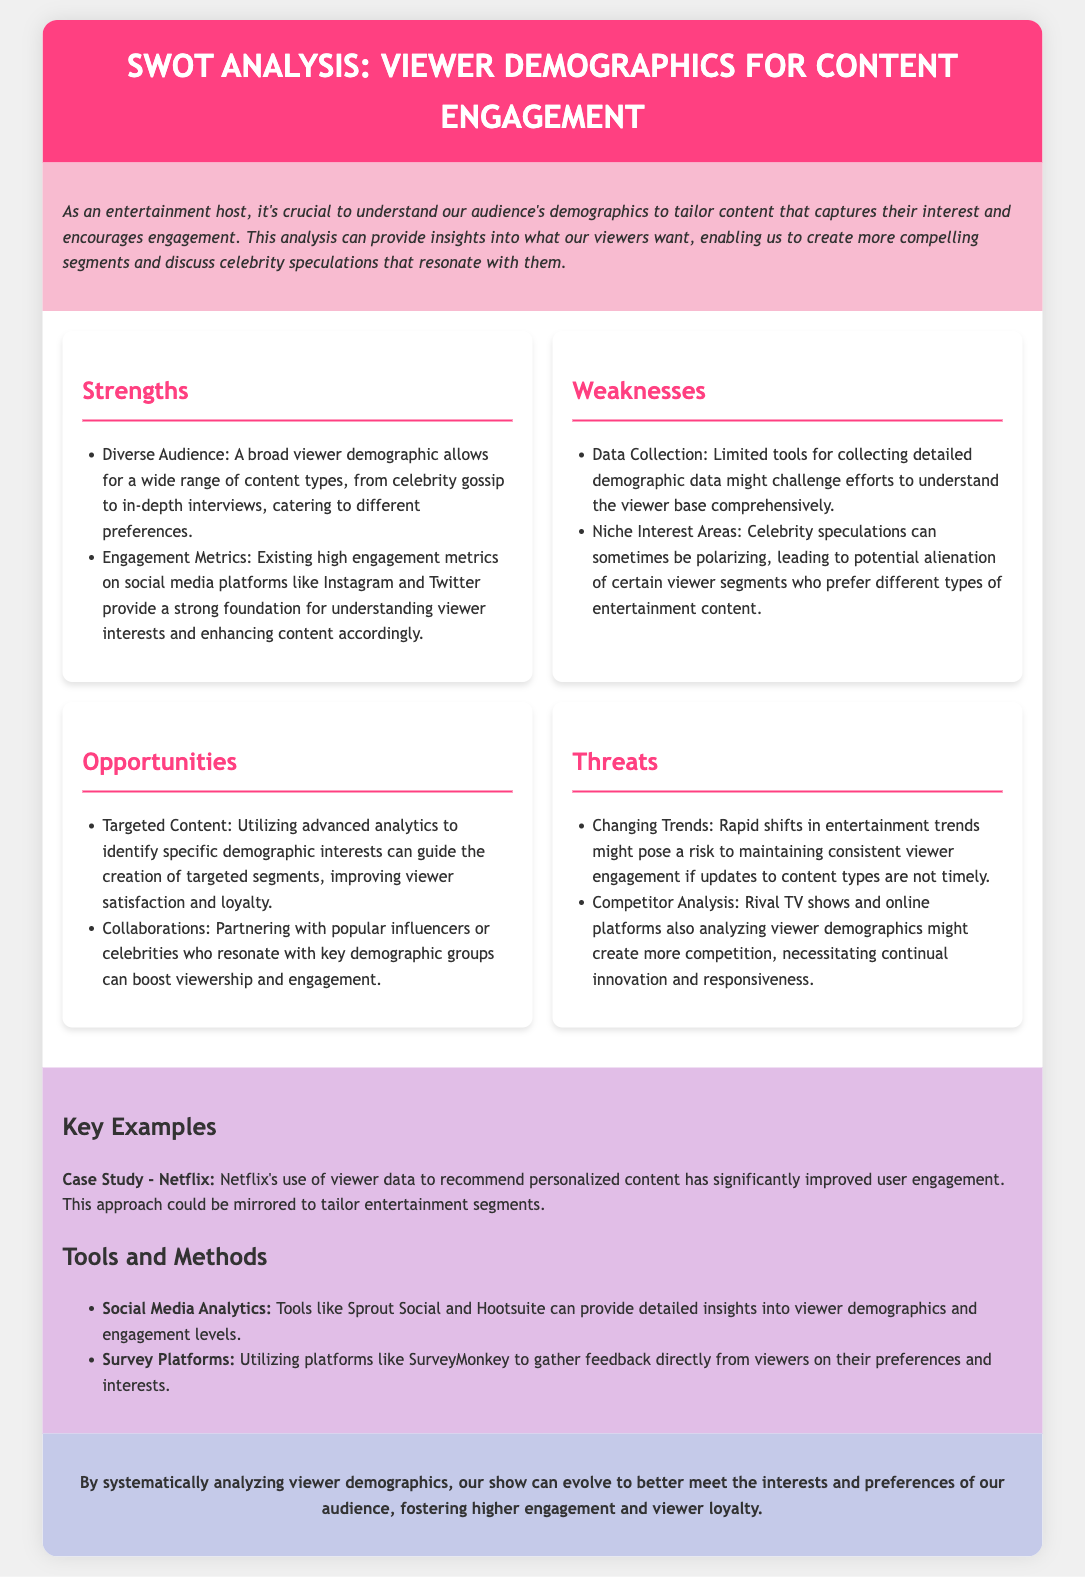What are the strengths mentioned in the analysis? The strengths listed in the analysis include diverse audience and engagement metrics.
Answer: Diverse Audience, Engagement Metrics What is one weakness identified in the document? The weaknesses noted in the document include limited tools for data collection.
Answer: Limited tools for collecting detailed demographic data What opportunity is highlighted for improving content engagement? The document suggests utilizing advanced analytics to identify specific demographic interests.
Answer: Utilizing advanced analytics What threat could impact viewer engagement according to the analysis? The analysis mentions changing trends as a threat to maintaining consistent viewer engagement.
Answer: Changing Trends What case study is provided as an example in the SWOT analysis? The case study mentioned is Netflix's use of viewer data for recommendations.
Answer: Netflix Which survey platform is recommended in the tools and methods section? The document recommends SurveyMonkey as a platform for gathering feedback.
Answer: SurveyMonkey How many strengths are listed in the SWOT analysis? There are two strengths mentioned in the SWOT analysis.
Answer: Two What is the conclusion about analyzing viewer demographics? The conclusion emphasizes that analyzing viewer demographics fosters higher engagement and viewer loyalty.
Answer: Higher engagement and viewer loyalty What is one method for collecting viewer demographic insights mentioned? Social Media Analytics is cited as a method for collecting demographic insights.
Answer: Social Media Analytics 